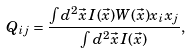Convert formula to latex. <formula><loc_0><loc_0><loc_500><loc_500>Q _ { i j } = \frac { \int d ^ { 2 } \vec { x } \, I ( \vec { x } ) W ( \vec { x } ) x _ { i } x _ { j } } { \int d ^ { 2 } \vec { x } \, I ( \vec { x } ) } ,</formula> 